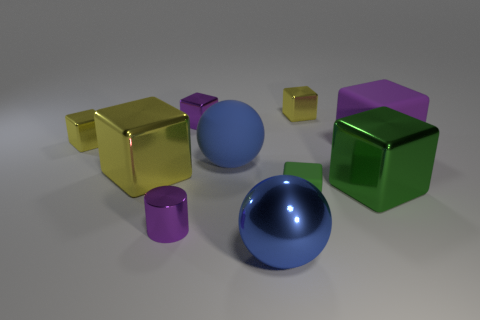Is the number of yellow blocks on the left side of the large shiny ball greater than the number of tiny yellow metal things on the right side of the small purple cylinder?
Ensure brevity in your answer.  Yes. Does the blue rubber object have the same size as the green metallic block?
Offer a terse response. Yes. The big rubber object that is to the left of the large shiny block right of the big blue metallic thing is what color?
Offer a terse response. Blue. What is the color of the small matte cube?
Ensure brevity in your answer.  Green. Is there a big metal cube that has the same color as the small matte thing?
Provide a short and direct response. Yes. There is a sphere that is behind the large shiny ball; is its color the same as the small cylinder?
Provide a short and direct response. No. How many objects are tiny yellow things that are to the left of the blue metal ball or blue balls?
Provide a succinct answer. 3. There is a blue matte thing; are there any green matte things to the right of it?
Make the answer very short. Yes. What material is the big block that is the same color as the tiny cylinder?
Your answer should be compact. Rubber. Is the material of the blue ball that is in front of the green rubber cube the same as the tiny purple cylinder?
Provide a short and direct response. Yes. 